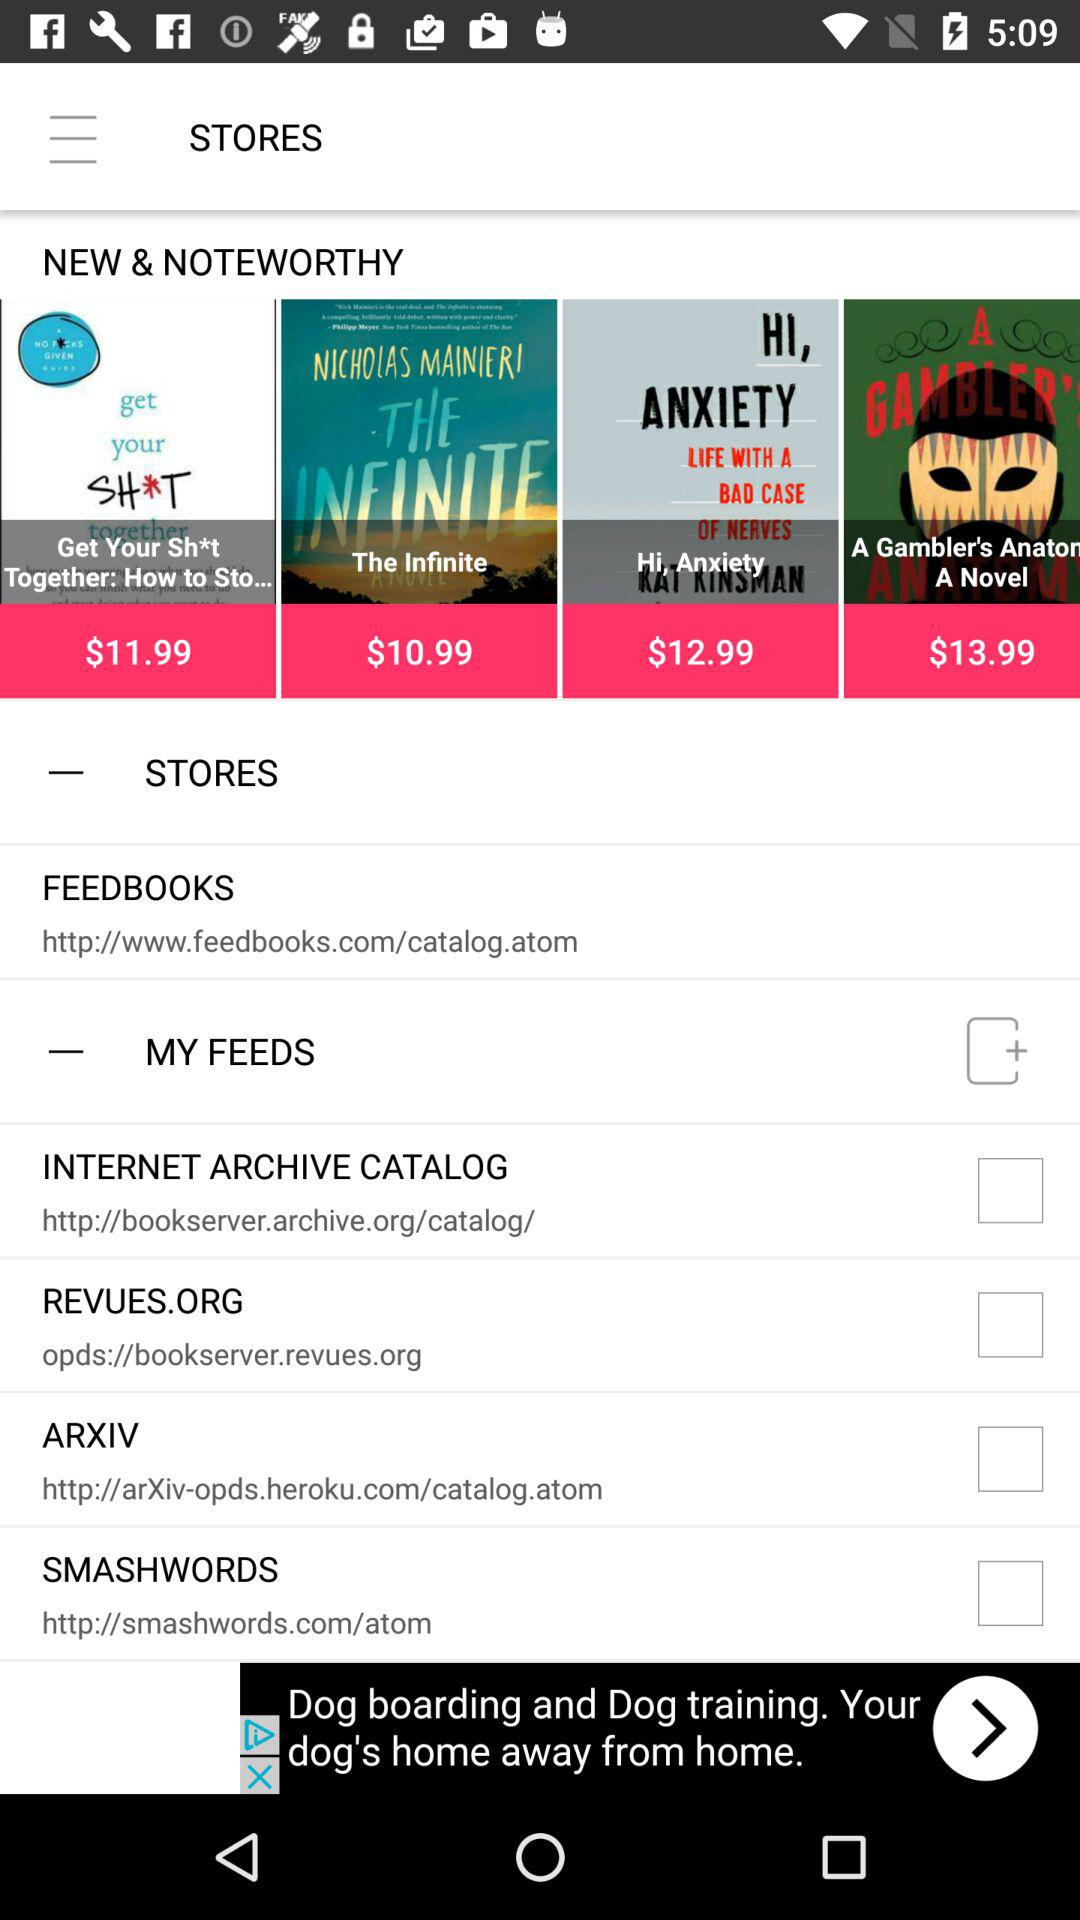What is the status of My Feeds?
When the provided information is insufficient, respond with <no answer>. <no answer> 